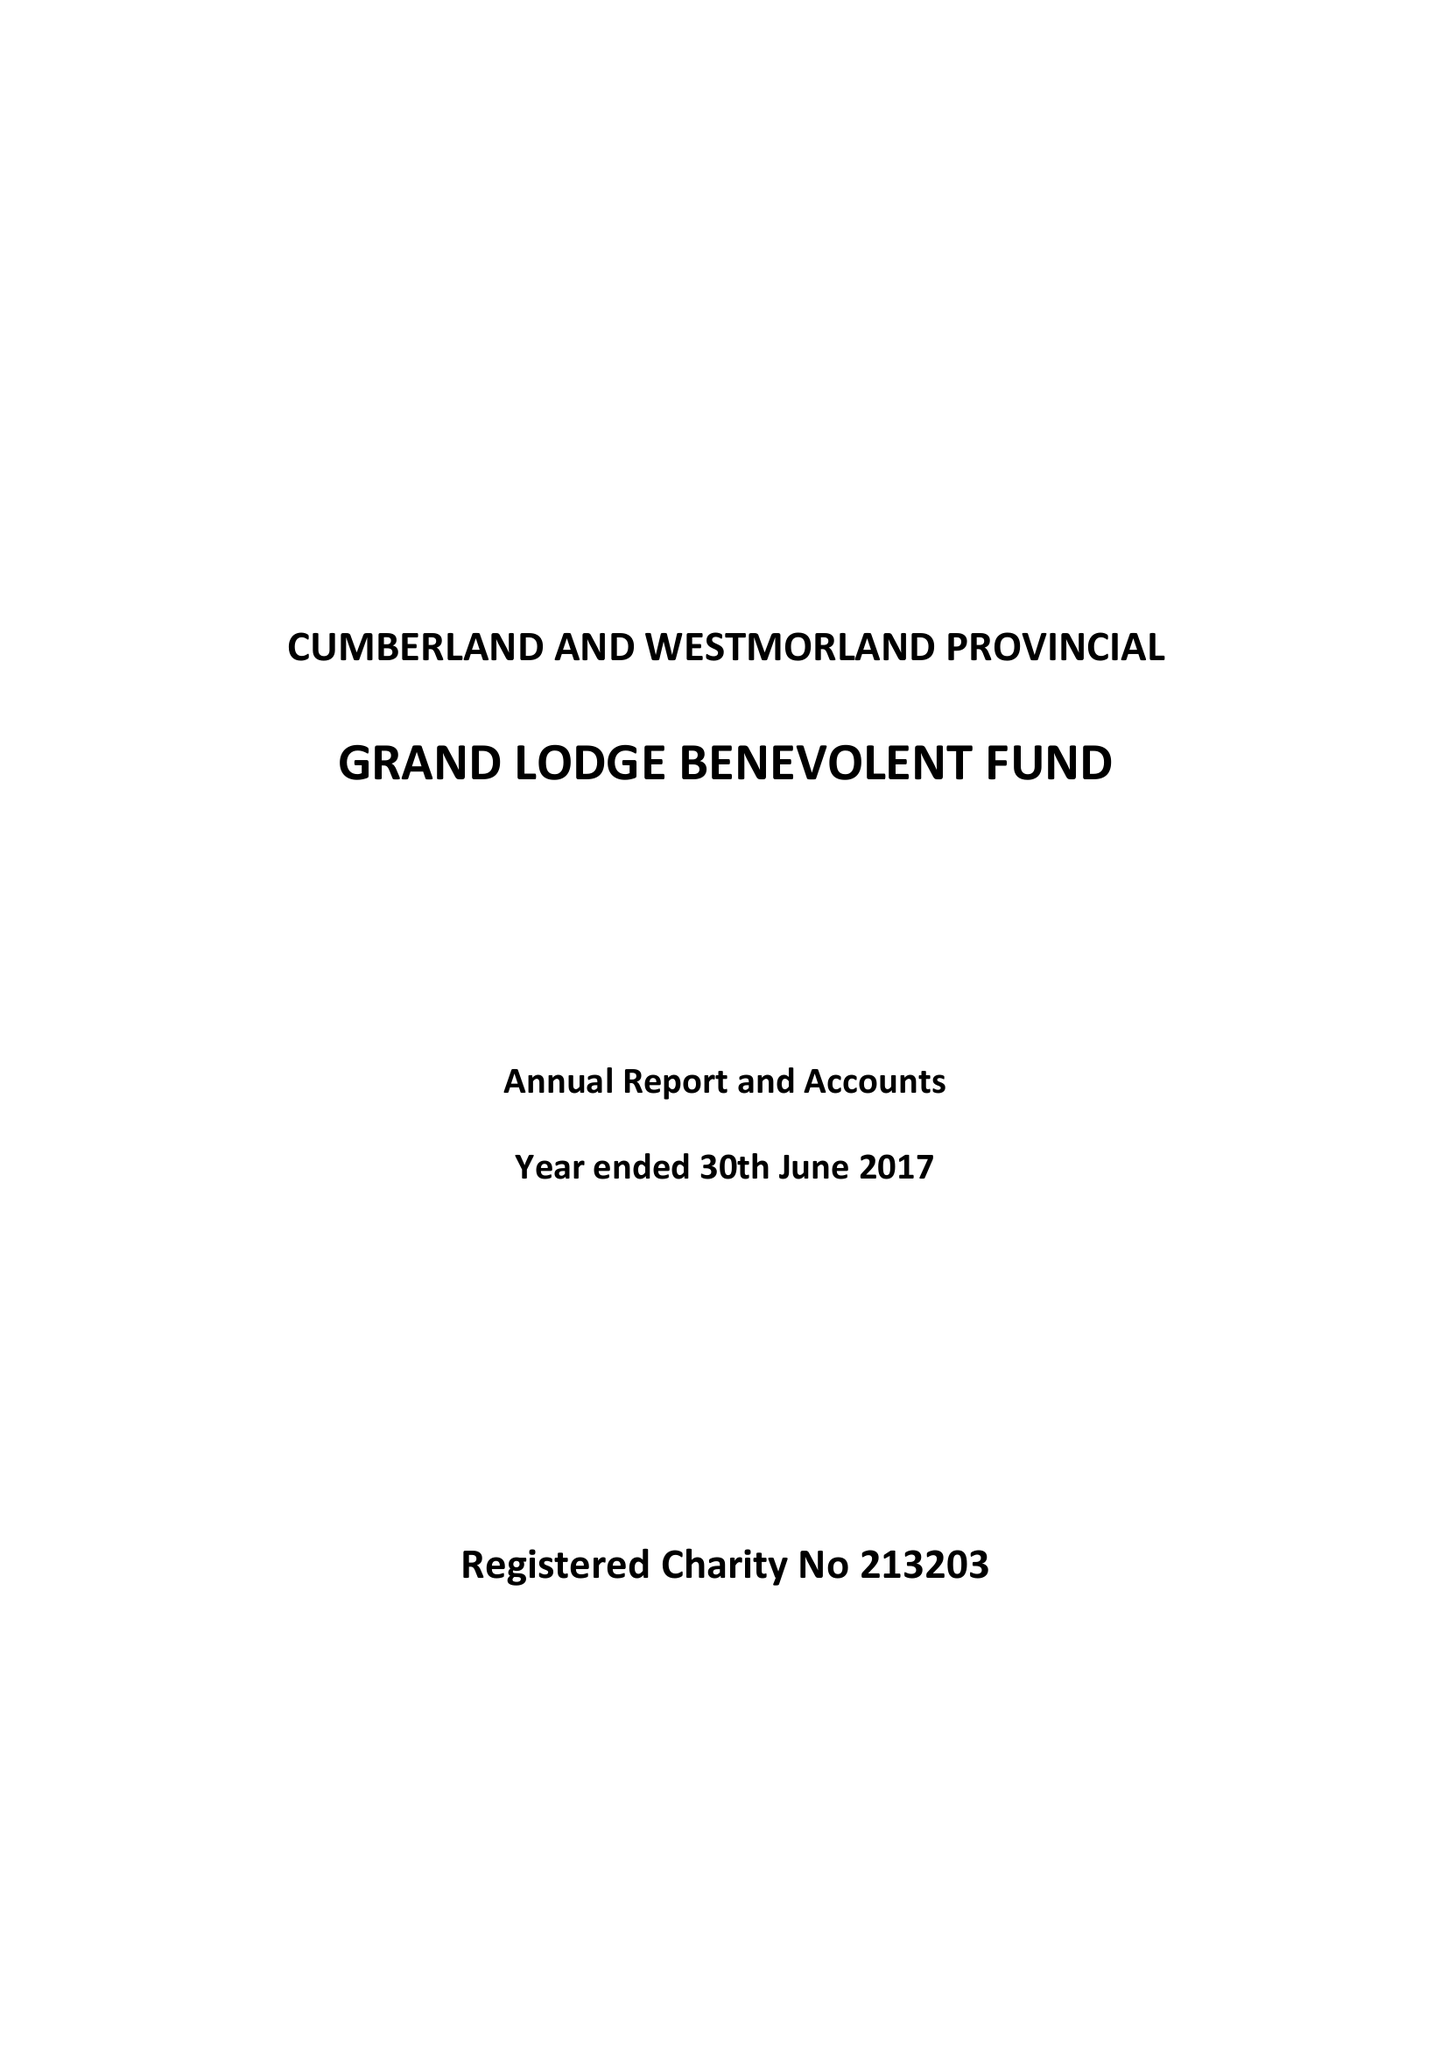What is the value for the charity_number?
Answer the question using a single word or phrase. 213203 